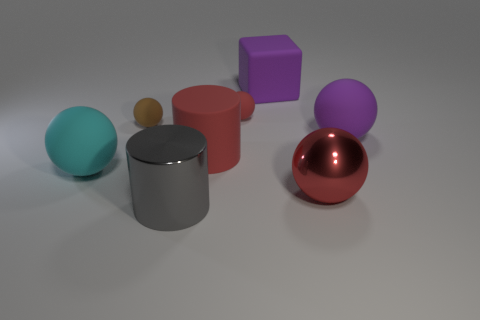Subtract all brown cubes. How many red balls are left? 2 Subtract 2 balls. How many balls are left? 3 Subtract all large matte balls. How many balls are left? 3 Subtract all cyan balls. How many balls are left? 4 Subtract all yellow balls. Subtract all yellow cylinders. How many balls are left? 5 Add 2 big blue cubes. How many objects exist? 10 Subtract all blocks. How many objects are left? 7 Subtract all small rubber spheres. Subtract all brown rubber spheres. How many objects are left? 5 Add 6 big red spheres. How many big red spheres are left? 7 Add 3 purple metal cylinders. How many purple metal cylinders exist? 3 